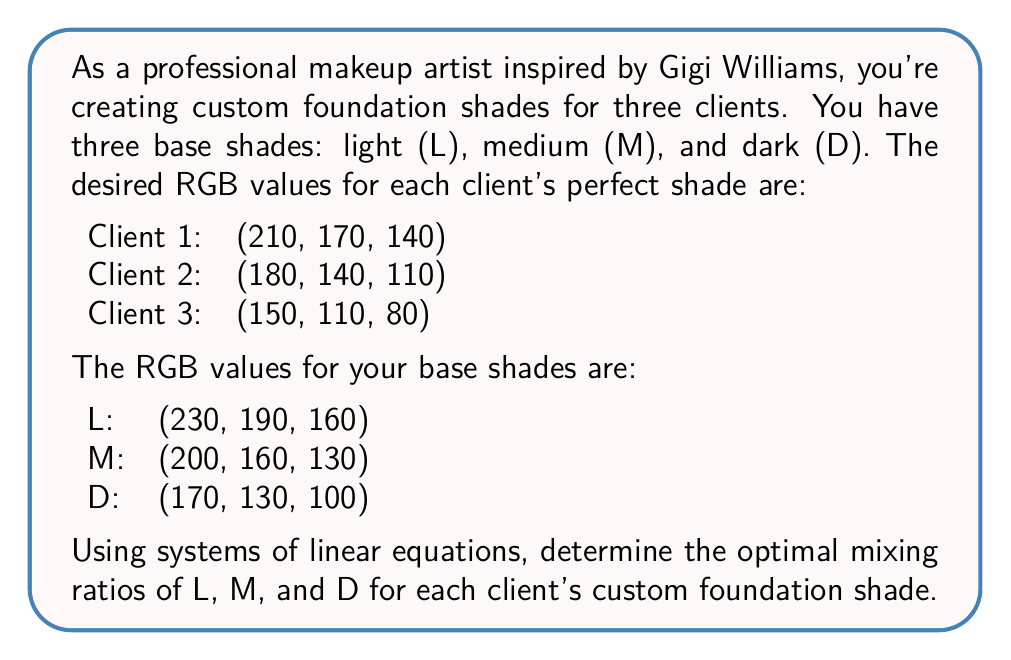Show me your answer to this math problem. Let's approach this step-by-step:

1) For each client, we need to find the mixing ratios $x$, $y$, and $z$ for L, M, and D respectively. These ratios must sum to 1:

   $x + y + z = 1$

2) For each RGB component, we can write an equation:

   $230x + 200y + 170z = R$
   $190x + 160y + 130z = G$
   $160x + 130y + 100z = B$

3) Let's solve for Client 1 (210, 170, 140):

   $$\begin{cases}
   x + y + z = 1 \\
   230x + 200y + 170z = 210 \\
   190x + 160y + 130z = 170 \\
   160x + 130y + 100z = 140
   \end{cases}$$

4) We can solve this system using matrix operations:

   $$\begin{bmatrix}
   1 & 1 & 1 \\
   230 & 200 & 170 \\
   190 & 160 & 130 \\
   160 & 130 & 100
   \end{bmatrix}
   \begin{bmatrix}
   x \\ y \\ z
   \end{bmatrix} =
   \begin{bmatrix}
   1 \\ 210 \\ 170 \\ 140
   \end{bmatrix}$$

5) Solving this system (using a calculator or computer algebra system) gives:

   Client 1: $x = 0.6667$, $y = 0.3333$, $z = 0$

6) Repeating the process for Clients 2 and 3:

   Client 2: $x = 0.3333$, $y = 0.3333$, $z = 0.3333$
   Client 3: $x = 0$, $y = 0.3333$, $z = 0.6667$

These ratios represent the optimal mixing proportions for each client's custom foundation shade.
Answer: Client 1: 2/3 L, 1/3 M, 0 D
Client 2: 1/3 L, 1/3 M, 1/3 D
Client 3: 0 L, 1/3 M, 2/3 D 